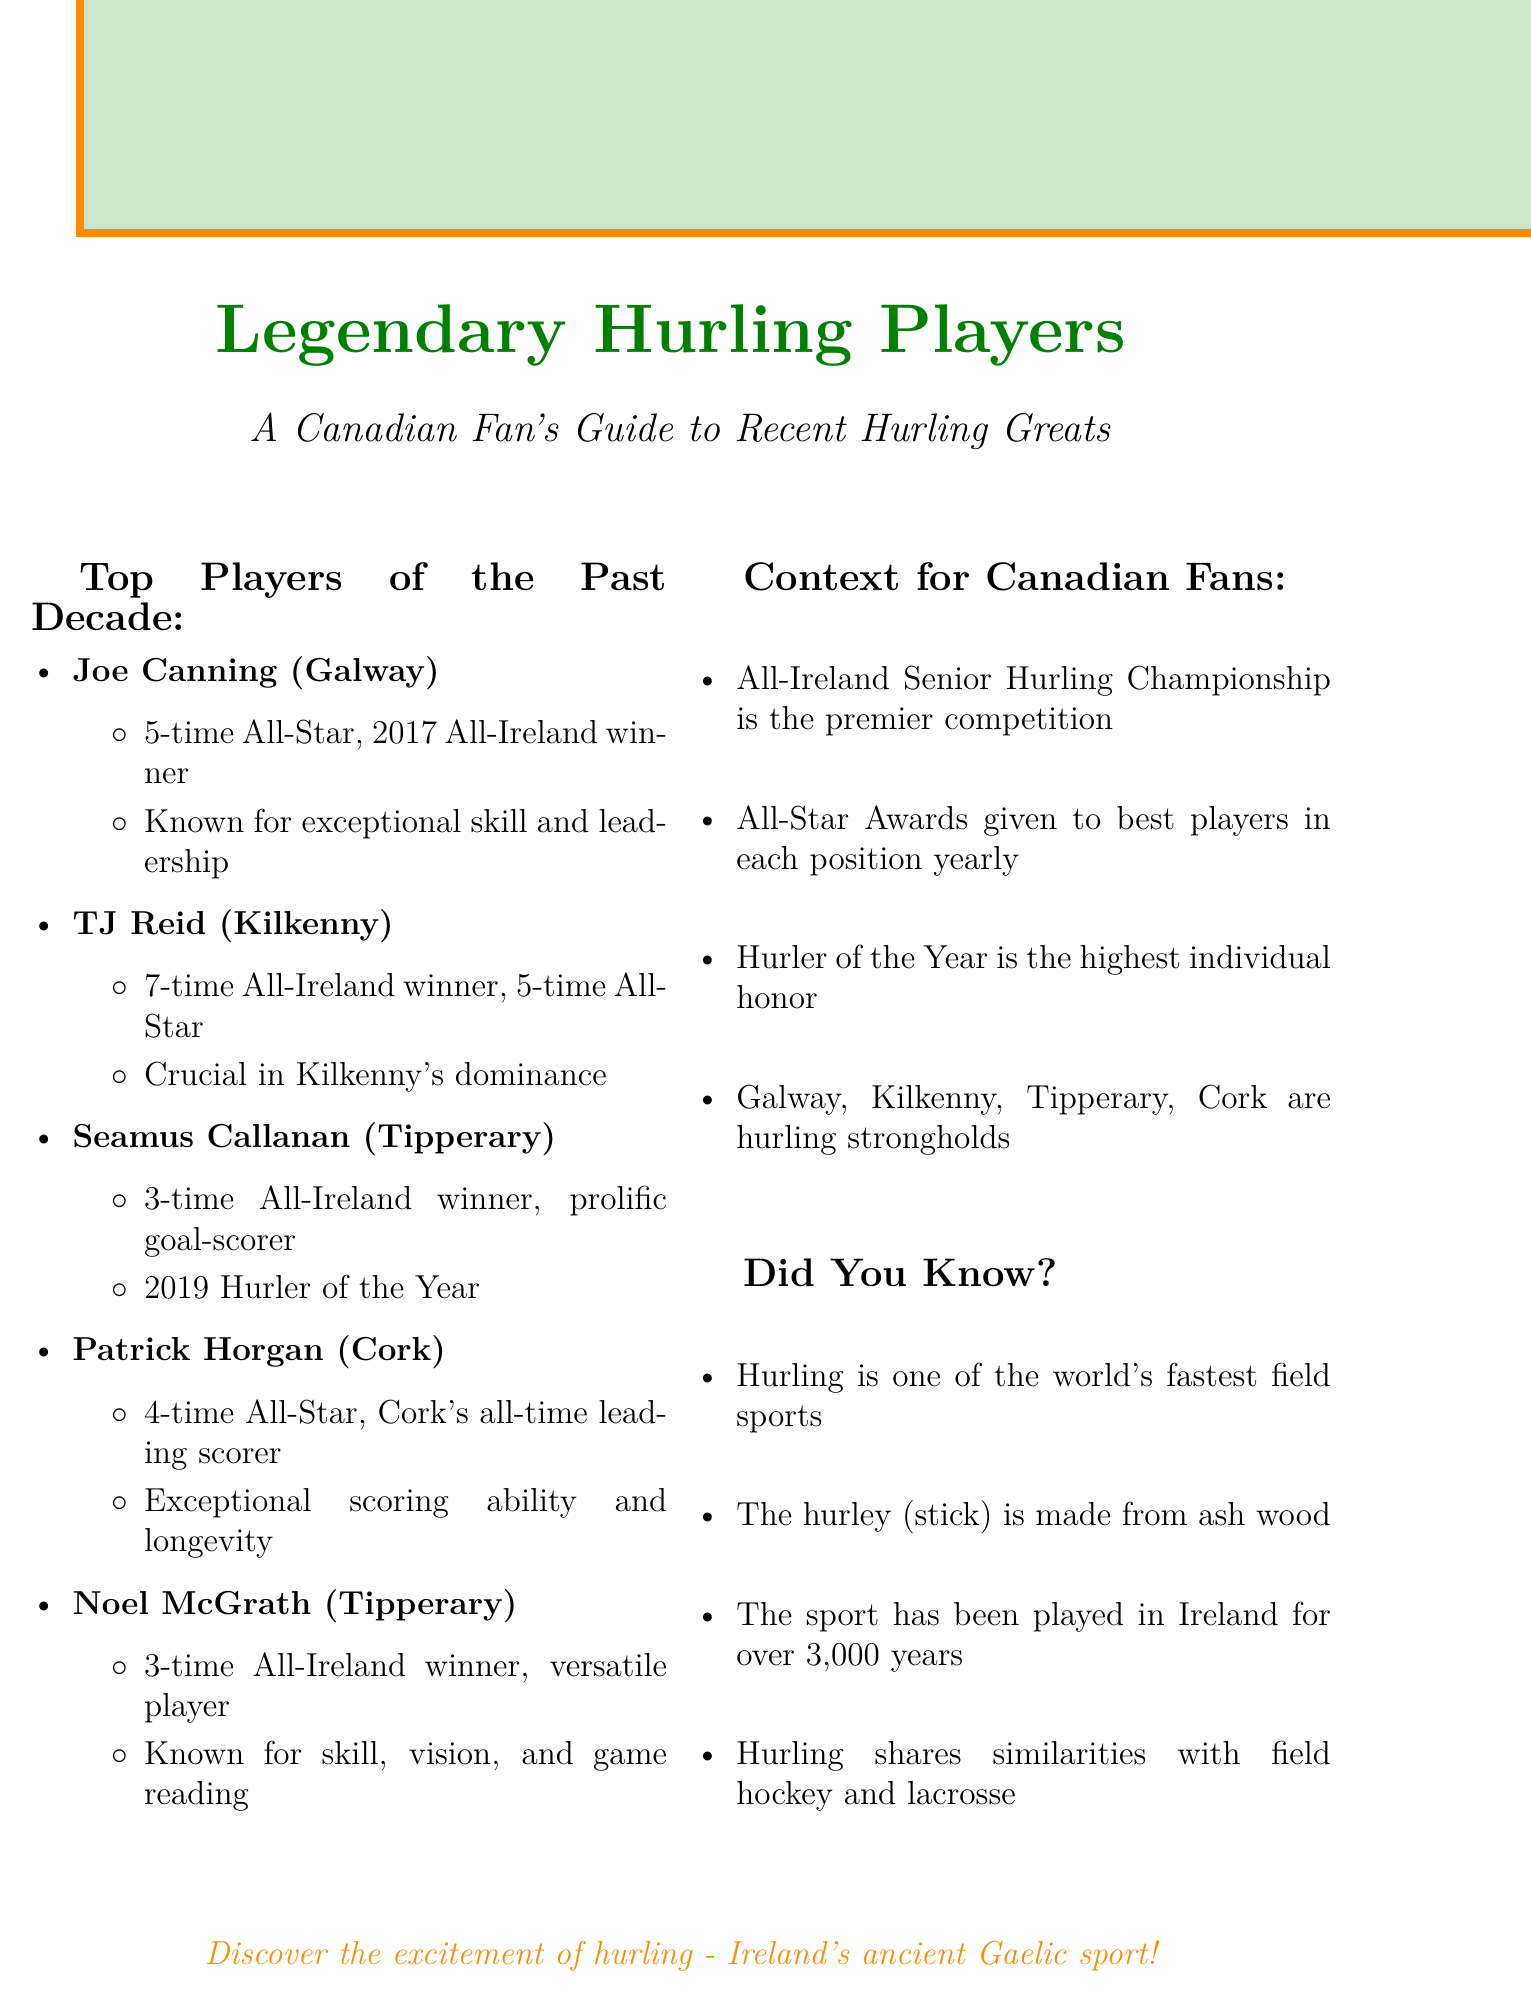What county is Joe Canning from? Joe Canning is listed as belonging to Galway in the document.
Answer: Galway How many All-Star Awards has TJ Reid won? TJ Reid's key achievements include winning 5 All-Star Awards.
Answer: 5 What year did Seamus Callanan win the Hurler of the Year award? The document specifies that Seamus Callanan won the Hurler of the Year award in 2019.
Answer: 2019 What is Patrick Horgan known for? The document highlights Patrick Horgan's exceptional scoring ability and longevity at the highest level.
Answer: Exceptional scoring ability How many times has Noel McGrath won the All-Ireland Senior Hurling Championship? Noel McGrath is noted to have won the All-Ireland Senior Hurling Championship 3 times.
Answer: 3 Why is TJ Reid considered a legend? He is recognized for consistent high-level performances and his crucial role in Kilkenny's dominance.
Answer: Consistent high-level performances What is the premier competition in hurling? The document states that the All-Ireland Senior Hurling Championship is the premier competition.
Answer: All-Ireland Senior Hurling Championship What type of wood is used to make a hurley? According to the document, hurleys are made from ash wood.
Answer: Ash wood Which counties are traditional strongholds of hurling? The document mentions Galway, Kilkenny, Tipperary, and Cork as traditional strongholds.
Answer: Galway, Kilkenny, Tipperary, Cork 